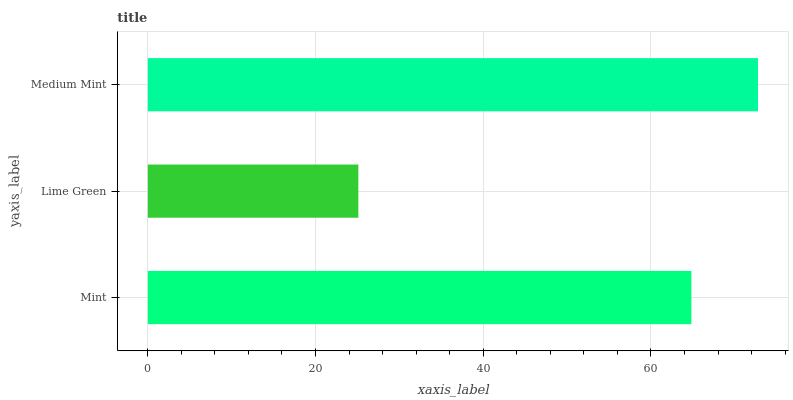Is Lime Green the minimum?
Answer yes or no. Yes. Is Medium Mint the maximum?
Answer yes or no. Yes. Is Medium Mint the minimum?
Answer yes or no. No. Is Lime Green the maximum?
Answer yes or no. No. Is Medium Mint greater than Lime Green?
Answer yes or no. Yes. Is Lime Green less than Medium Mint?
Answer yes or no. Yes. Is Lime Green greater than Medium Mint?
Answer yes or no. No. Is Medium Mint less than Lime Green?
Answer yes or no. No. Is Mint the high median?
Answer yes or no. Yes. Is Mint the low median?
Answer yes or no. Yes. Is Lime Green the high median?
Answer yes or no. No. Is Lime Green the low median?
Answer yes or no. No. 